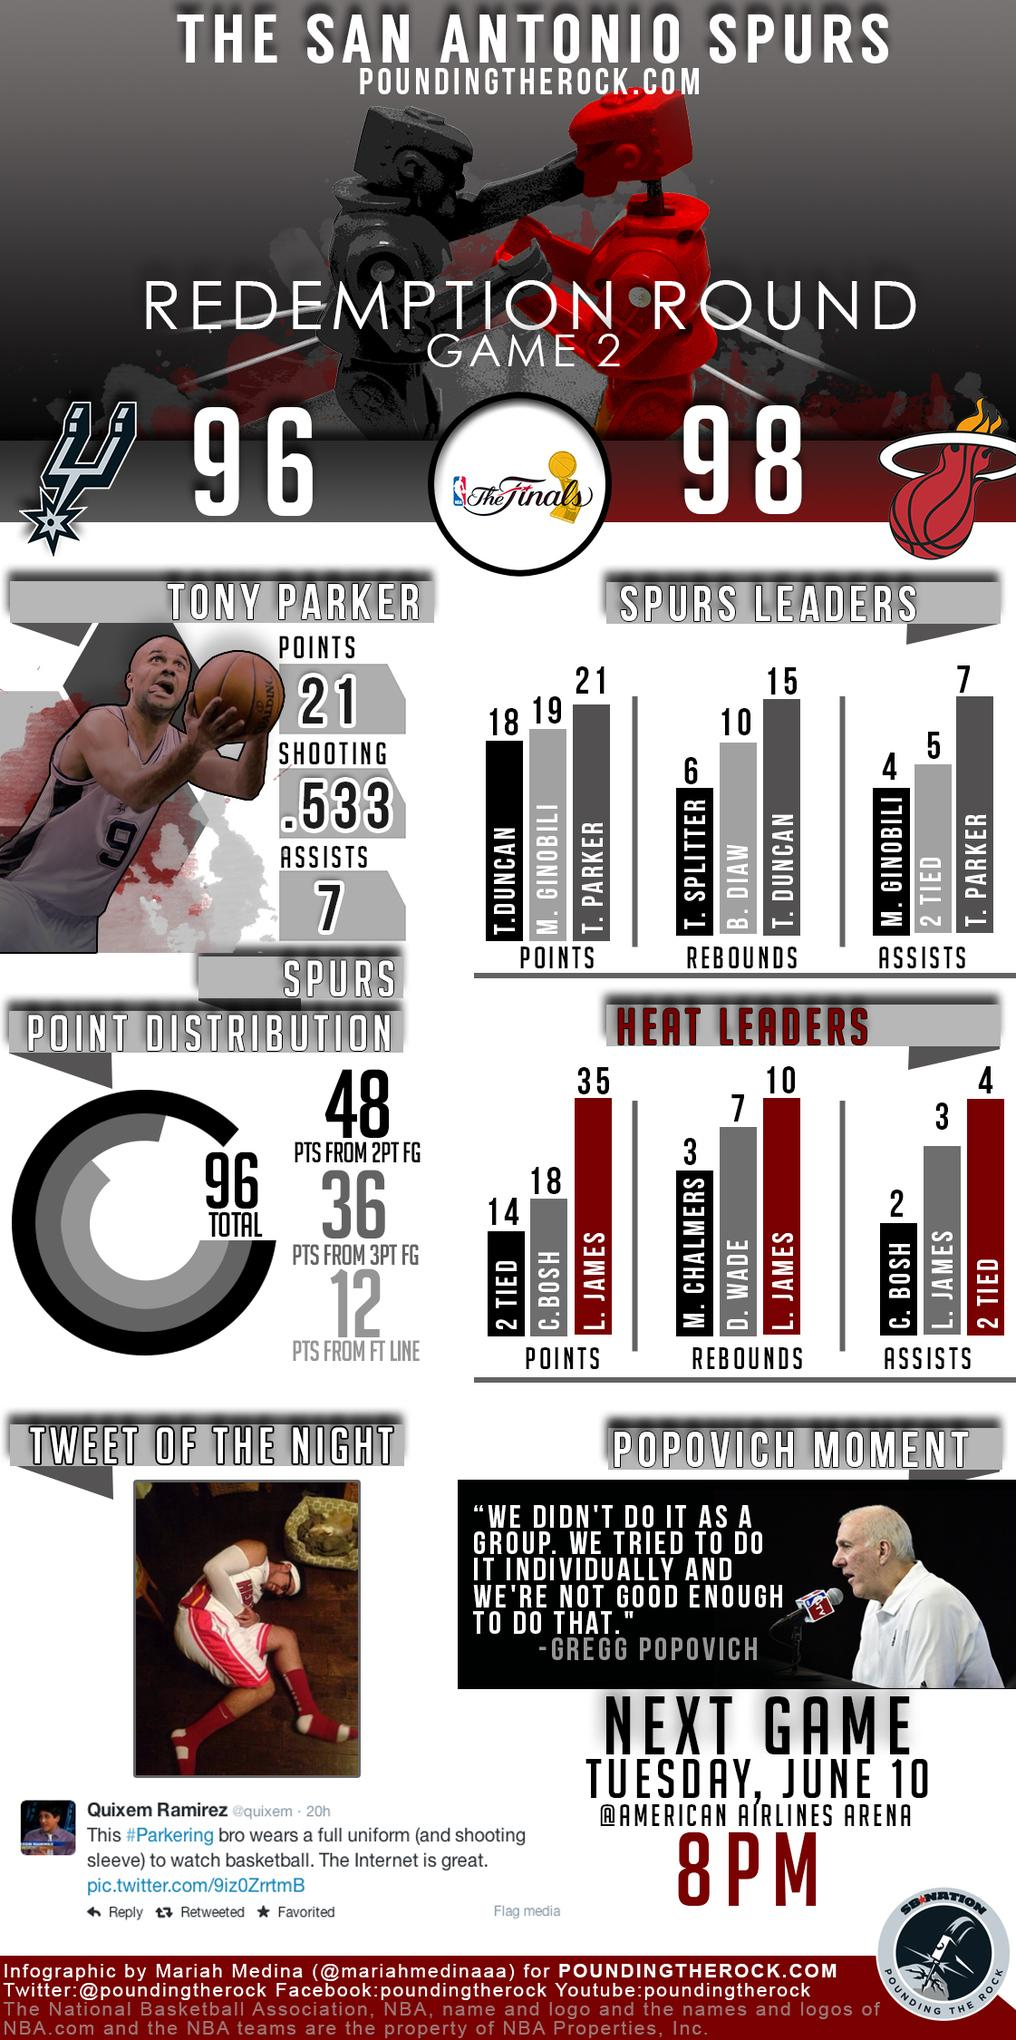Outline some significant characteristics in this image. Tony Parker has recorded a total of 7 Assists. Based on the information provided, there were 12 assists made by Tony Parker and two of them were tied, with these figures being among the top contributions from Spurs leaders. In total, Tony Parker scored 21 points. The Spurs leaders B. Dian and T. Duncan combined for 25 rebounds. The total number of points scored by Tony Parker and Tim Duncan, taken together from the leaders of the San Antonio Spurs, is 39. 